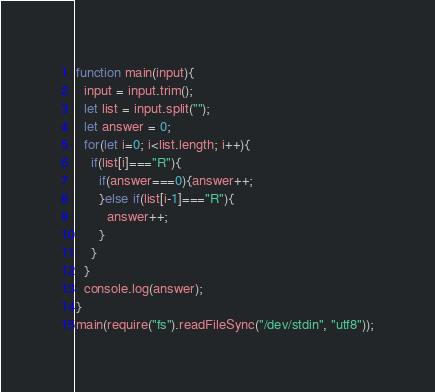Convert code to text. <code><loc_0><loc_0><loc_500><loc_500><_JavaScript_>function main(input){
  input = input.trim();
  let list = input.split("");
  let answer = 0;
  for(let i=0; i<list.length; i++){
    if(list[i]==="R"){
      if(answer===0){answer++;
      }else if(list[i-1]==="R"){
        answer++;
      }                 
    }
  }
  console.log(answer);
}
main(require("fs").readFileSync("/dev/stdin", "utf8"));</code> 